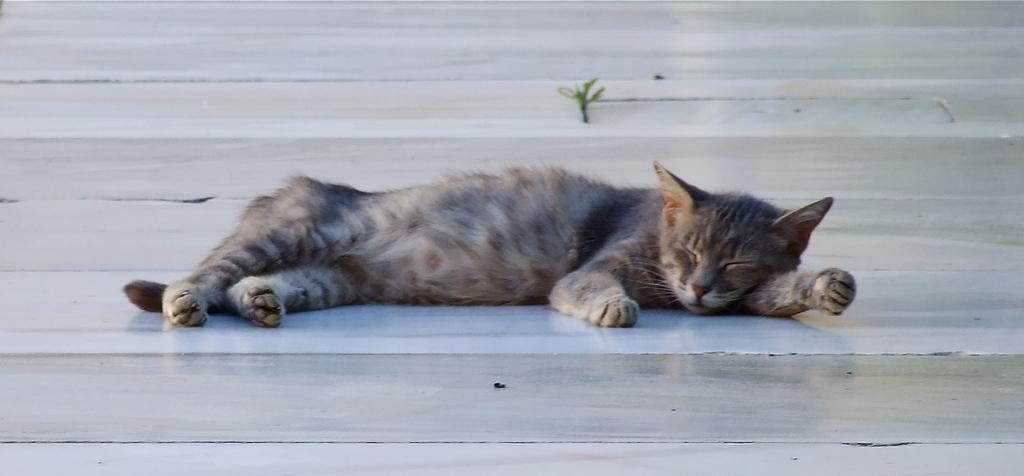What type of animal is present in the image? There is a cat in the image. What is the cat doing in the image? The cat is lying on the ground and sleeping. What type of boot is covering the cat's paws in the image? There is no boot present in the image; the cat's paws are not covered. 